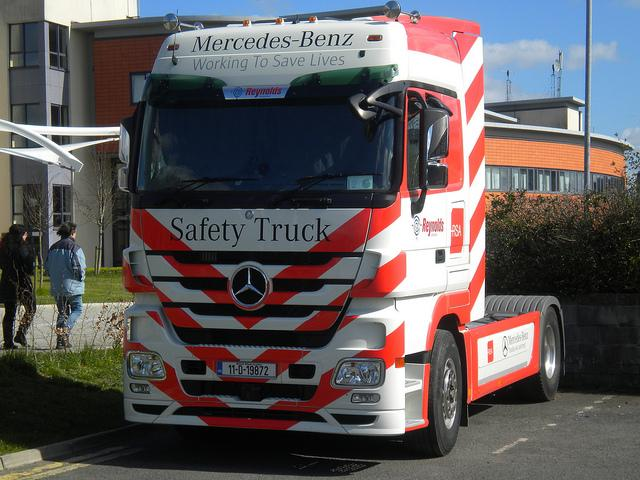What is the most appropriate surface for this truck to drive on? road 